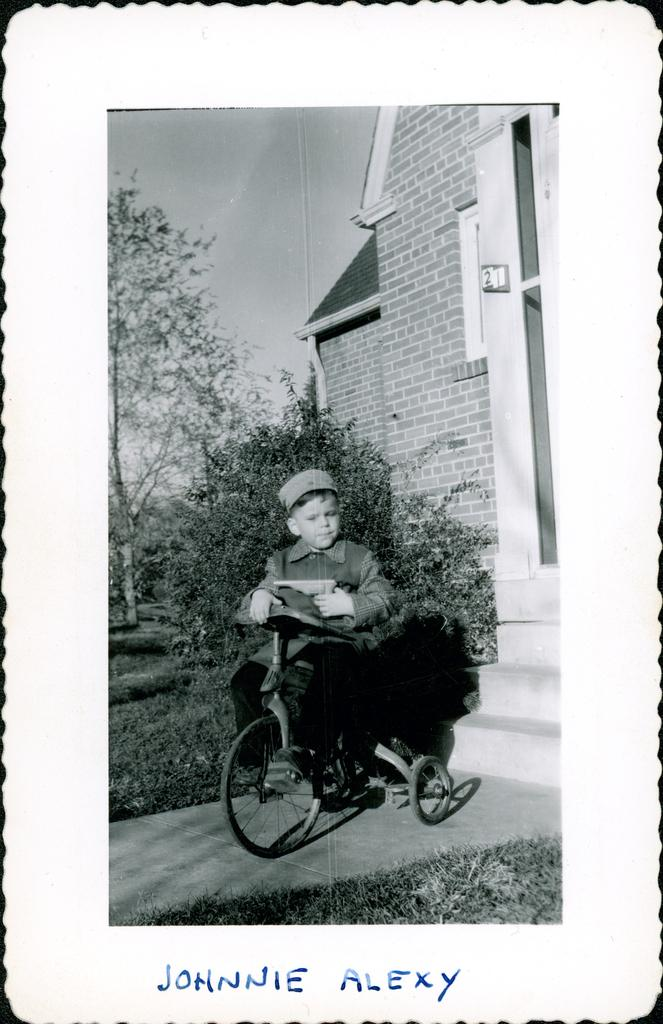What is the main subject of the photo in the image? There is a photo of a person sitting on a bicycle. What can be seen in the background of the photo? There is a house behind the person. What type of vegetation is present in the image? Trees, plants, and grass are visible in the image. Is there any text in the image? Yes, there is some text at the bottom of the image. What type of nose can be seen on the bicycle in the image? There is no nose present on the bicycle in the image. What type of joke is being told by the person on the bicycle in the image? There is no joke being told by the person on the bicycle in the image. 